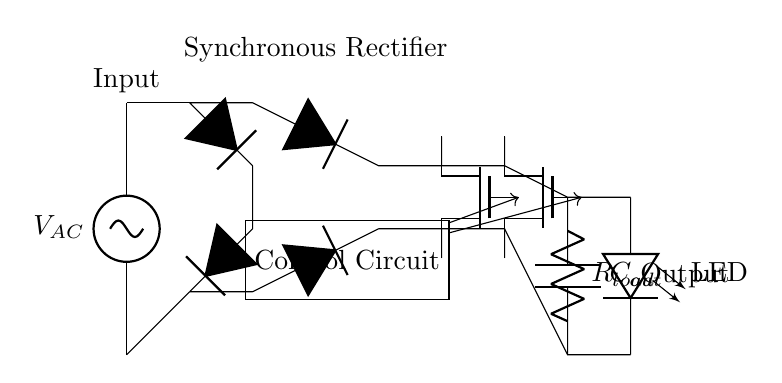What is the input type for this circuit? The input type is alternating current, as indicated by the label on the voltage source at the beginning of the circuit.
Answer: Alternating current What components are used in the rectification process? The rectification process in this circuit involves diodes and synchronous rectifier MOSFETs. The diodes are represented as D stars in the diagram, and the MOSFETs are labeled as Tnmos.
Answer: Diodes and MOSFETs How many MOSFETs are used in this circuit? There are two MOSFETs present in the circuit, identified as M1 and M2, both connected in the synchronous rectification part of the circuit.
Answer: Two What is the function of the control circuit in this diagram? The control circuit is responsible for managing the operation of the two MOSFETs, ensuring they are turned on and off at the correct times to efficiently regulate the output voltage.
Answer: Management of MOSFET operation What is the purpose of the capacitor labeled Cout? The capacitor Cout is used to smooth out the rectified voltage, providing a stable output voltage for the LED load and reducing voltage ripple.
Answer: Smoothing rectified voltage How does the synchronous rectifier improve efficiency compared to a conventional rectifier? The synchronous rectifier uses controlled MOSFETs instead of traditional diodes, reducing voltage drop and power loss during rectification, which leads to higher efficiency in converting AC to DC.
Answer: Higher efficiency 